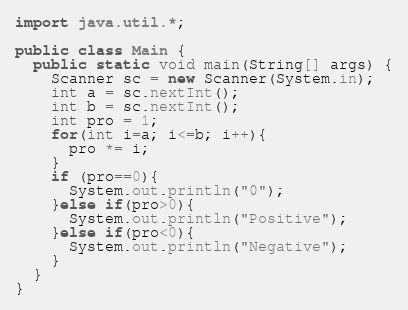Convert code to text. <code><loc_0><loc_0><loc_500><loc_500><_Java_>import java.util.*;

public class Main {
  public static void main(String[] args) {
    Scanner sc = new Scanner(System.in);
    int a = sc.nextInt();
    int b = sc.nextInt();
    int pro = 1;
    for(int i=a; i<=b; i++){
      pro *= i;
    }
    if (pro==0){
      System.out.println("0");
    }else if(pro>0){
      System.out.println("Positive");
    }else if(pro<0){
      System.out.println("Negative");
    }
  }
}</code> 